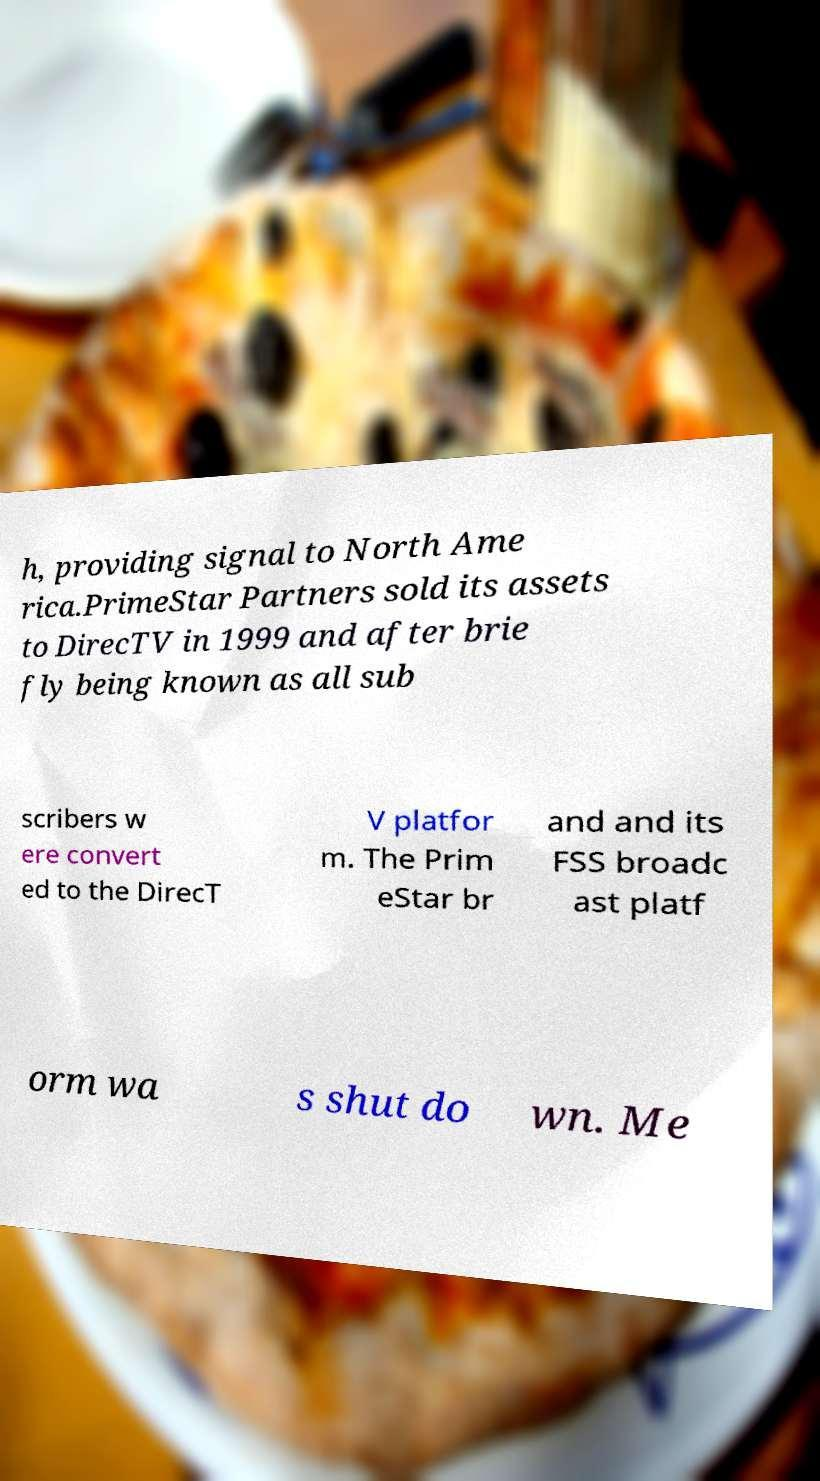For documentation purposes, I need the text within this image transcribed. Could you provide that? h, providing signal to North Ame rica.PrimeStar Partners sold its assets to DirecTV in 1999 and after brie fly being known as all sub scribers w ere convert ed to the DirecT V platfor m. The Prim eStar br and and its FSS broadc ast platf orm wa s shut do wn. Me 